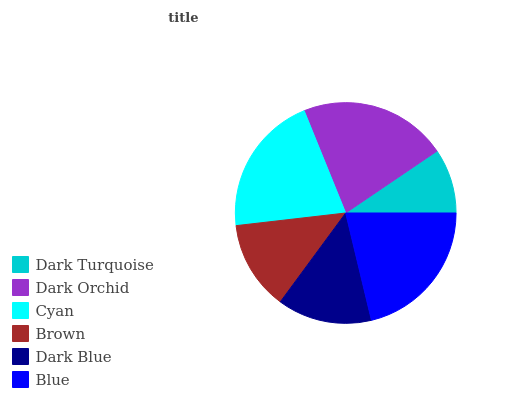Is Dark Turquoise the minimum?
Answer yes or no. Yes. Is Dark Orchid the maximum?
Answer yes or no. Yes. Is Cyan the minimum?
Answer yes or no. No. Is Cyan the maximum?
Answer yes or no. No. Is Dark Orchid greater than Cyan?
Answer yes or no. Yes. Is Cyan less than Dark Orchid?
Answer yes or no. Yes. Is Cyan greater than Dark Orchid?
Answer yes or no. No. Is Dark Orchid less than Cyan?
Answer yes or no. No. Is Cyan the high median?
Answer yes or no. Yes. Is Dark Blue the low median?
Answer yes or no. Yes. Is Dark Orchid the high median?
Answer yes or no. No. Is Dark Turquoise the low median?
Answer yes or no. No. 